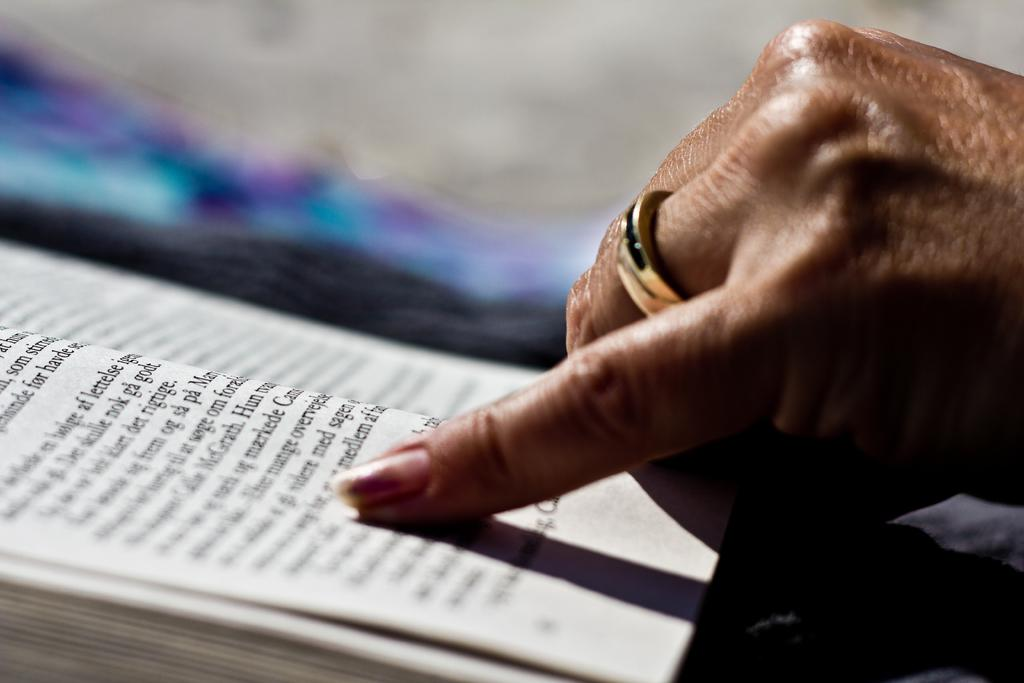Who or what is the main subject in the image? There is a person in the image. What can be seen on the person's hand? The person's hand has a ring on it. What is the person's finger touching in the image? The person's finger is on a book. What type of animal can be seen in the image? There is no animal present in the image. 